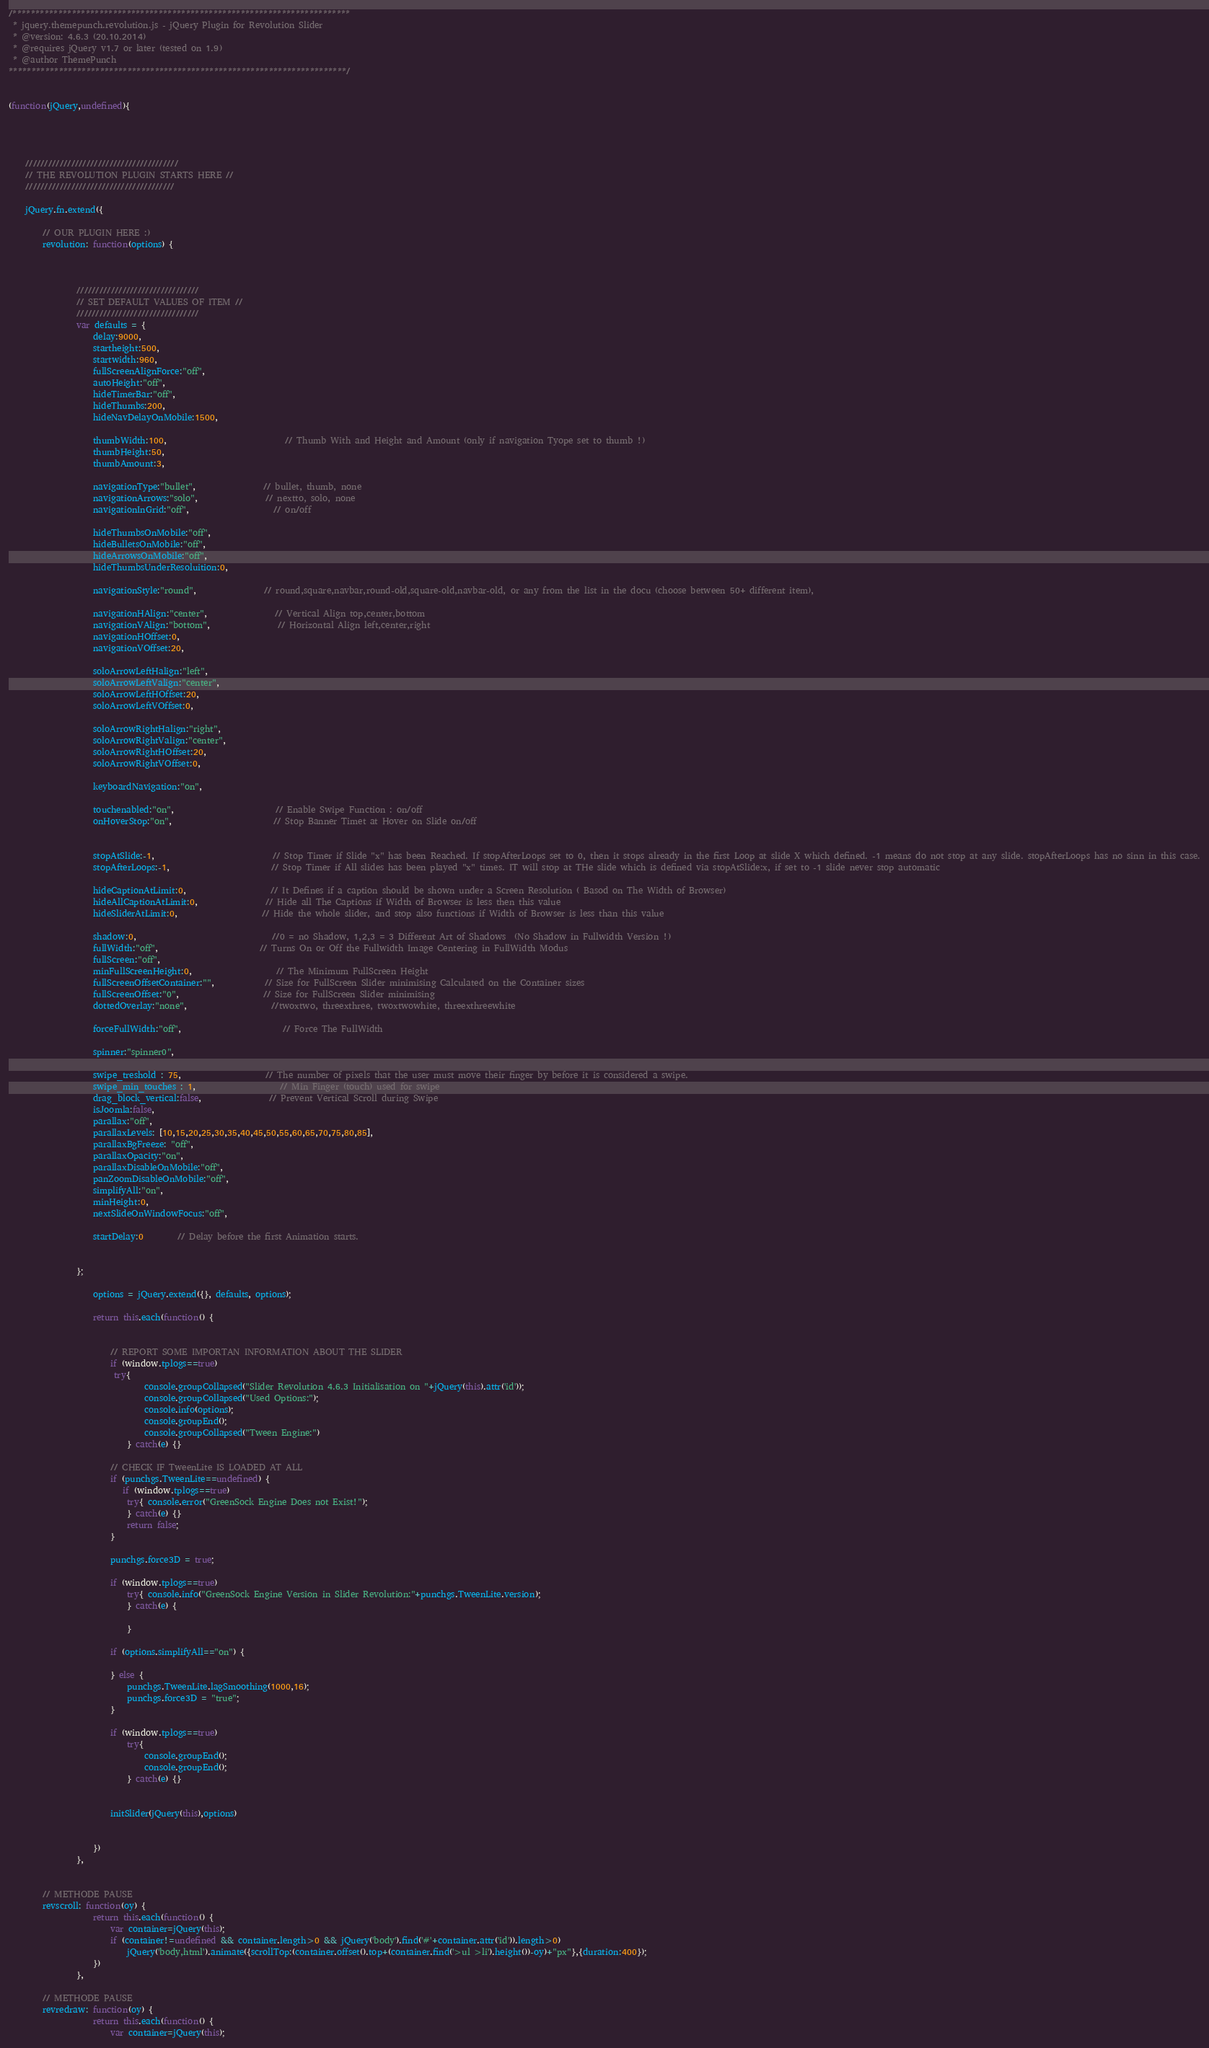<code> <loc_0><loc_0><loc_500><loc_500><_JavaScript_>/**************************************************************************
 * jquery.themepunch.revolution.js - jQuery Plugin for Revolution Slider
 * @version: 4.6.3 (20.10.2014)
 * @requires jQuery v1.7 or later (tested on 1.9)
 * @author ThemePunch
**************************************************************************/


(function(jQuery,undefined){




	////////////////////////////////////////
	// THE REVOLUTION PLUGIN STARTS HERE //
	///////////////////////////////////////

	jQuery.fn.extend({

		// OUR PLUGIN HERE :)
		revolution: function(options) {



				////////////////////////////////
				// SET DEFAULT VALUES OF ITEM //
				////////////////////////////////
				var defaults = {
					delay:9000,
					startheight:500,
					startwidth:960,
					fullScreenAlignForce:"off",
					autoHeight:"off",
					hideTimerBar:"off",
					hideThumbs:200,
					hideNavDelayOnMobile:1500,

					thumbWidth:100,							// Thumb With and Height and Amount (only if navigation Tyope set to thumb !)
					thumbHeight:50,
					thumbAmount:3,

					navigationType:"bullet",				// bullet, thumb, none
					navigationArrows:"solo",				// nextto, solo, none
					navigationInGrid:"off",					// on/off

					hideThumbsOnMobile:"off",
					hideBulletsOnMobile:"off",
					hideArrowsOnMobile:"off",
					hideThumbsUnderResoluition:0,

					navigationStyle:"round",				// round,square,navbar,round-old,square-old,navbar-old, or any from the list in the docu (choose between 50+ different item),

					navigationHAlign:"center",				// Vertical Align top,center,bottom
					navigationVAlign:"bottom",				// Horizontal Align left,center,right
					navigationHOffset:0,
					navigationVOffset:20,

					soloArrowLeftHalign:"left",
					soloArrowLeftValign:"center",
					soloArrowLeftHOffset:20,
					soloArrowLeftVOffset:0,

					soloArrowRightHalign:"right",
					soloArrowRightValign:"center",
					soloArrowRightHOffset:20,
					soloArrowRightVOffset:0,

					keyboardNavigation:"on",

					touchenabled:"on",						// Enable Swipe Function : on/off
					onHoverStop:"on",						// Stop Banner Timet at Hover on Slide on/off


					stopAtSlide:-1,							// Stop Timer if Slide "x" has been Reached. If stopAfterLoops set to 0, then it stops already in the first Loop at slide X which defined. -1 means do not stop at any slide. stopAfterLoops has no sinn in this case.
					stopAfterLoops:-1,						// Stop Timer if All slides has been played "x" times. IT will stop at THe slide which is defined via stopAtSlide:x, if set to -1 slide never stop automatic

					hideCaptionAtLimit:0,					// It Defines if a caption should be shown under a Screen Resolution ( Basod on The Width of Browser)
					hideAllCaptionAtLimit:0,				// Hide all The Captions if Width of Browser is less then this value
					hideSliderAtLimit:0,					// Hide the whole slider, and stop also functions if Width of Browser is less than this value

					shadow:0,								//0 = no Shadow, 1,2,3 = 3 Different Art of Shadows  (No Shadow in Fullwidth Version !)
					fullWidth:"off",						// Turns On or Off the Fullwidth Image Centering in FullWidth Modus
					fullScreen:"off",
					minFullScreenHeight:0,					// The Minimum FullScreen Height
					fullScreenOffsetContainer:"",			// Size for FullScreen Slider minimising Calculated on the Container sizes
					fullScreenOffset:"0",					// Size for FullScreen Slider minimising
					dottedOverlay:"none",					//twoxtwo, threexthree, twoxtwowhite, threexthreewhite

					forceFullWidth:"off",						// Force The FullWidth

					spinner:"spinner0",

					swipe_treshold : 75,					// The number of pixels that the user must move their finger by before it is considered a swipe.
					swipe_min_touches : 1,					// Min Finger (touch) used for swipe
					drag_block_vertical:false,				// Prevent Vertical Scroll during Swipe
					isJoomla:false,
					parallax:"off",
					parallaxLevels: [10,15,20,25,30,35,40,45,50,55,60,65,70,75,80,85],
					parallaxBgFreeze: "off",
					parallaxOpacity:"on",
					parallaxDisableOnMobile:"off",
					panZoomDisableOnMobile:"off",
					simplifyAll:"on",
					minHeight:0,
					nextSlideOnWindowFocus:"off",

					startDelay:0		// Delay before the first Animation starts.


				};

					options = jQuery.extend({}, defaults, options);

					return this.each(function() {


						// REPORT SOME IMPORTAN INFORMATION ABOUT THE SLIDER
						if (window.tplogs==true)
						 try{
								console.groupCollapsed("Slider Revolution 4.6.3 Initialisation on "+jQuery(this).attr('id'));
								console.groupCollapsed("Used Options:");
								console.info(options);
								console.groupEnd();
								console.groupCollapsed("Tween Engine:")
							} catch(e) {}

						// CHECK IF TweenLite IS LOADED AT ALL
						if (punchgs.TweenLite==undefined) {
						   if (window.tplogs==true)
						    try{ console.error("GreenSock Engine Does not Exist!");
						    } catch(e) {}
							return false;
						}

						punchgs.force3D = true;

						if (window.tplogs==true)
							try{ console.info("GreenSock Engine Version in Slider Revolution:"+punchgs.TweenLite.version);
							} catch(e) {

							}

						if (options.simplifyAll=="on") {

						} else {
							punchgs.TweenLite.lagSmoothing(1000,16);
							punchgs.force3D = "true";
						}

						if (window.tplogs==true)
							try{
								console.groupEnd();
								console.groupEnd();
							} catch(e) {}


						initSlider(jQuery(this),options)


					})
				},


		// METHODE PAUSE
		revscroll: function(oy) {
					return this.each(function() {
						var container=jQuery(this);
						if (container!=undefined && container.length>0 && jQuery('body').find('#'+container.attr('id')).length>0)
							jQuery('body,html').animate({scrollTop:(container.offset().top+(container.find('>ul >li').height())-oy)+"px"},{duration:400});
					})
				},

		// METHODE PAUSE
		revredraw: function(oy) {
					return this.each(function() {
						var container=jQuery(this);</code> 